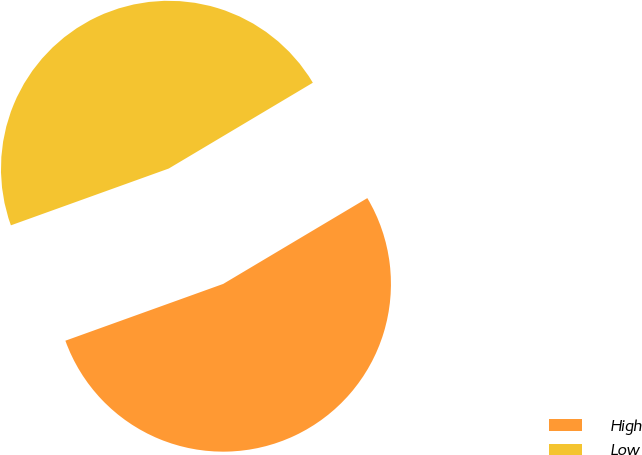Convert chart. <chart><loc_0><loc_0><loc_500><loc_500><pie_chart><fcel>High<fcel>Low<nl><fcel>53.05%<fcel>46.95%<nl></chart> 